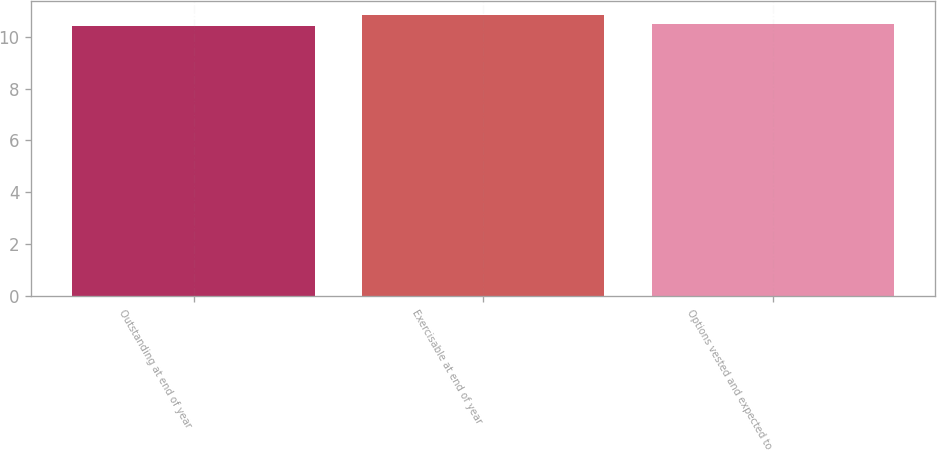Convert chart to OTSL. <chart><loc_0><loc_0><loc_500><loc_500><bar_chart><fcel>Outstanding at end of year<fcel>Exercisable at end of year<fcel>Options vested and expected to<nl><fcel>10.42<fcel>10.85<fcel>10.49<nl></chart> 